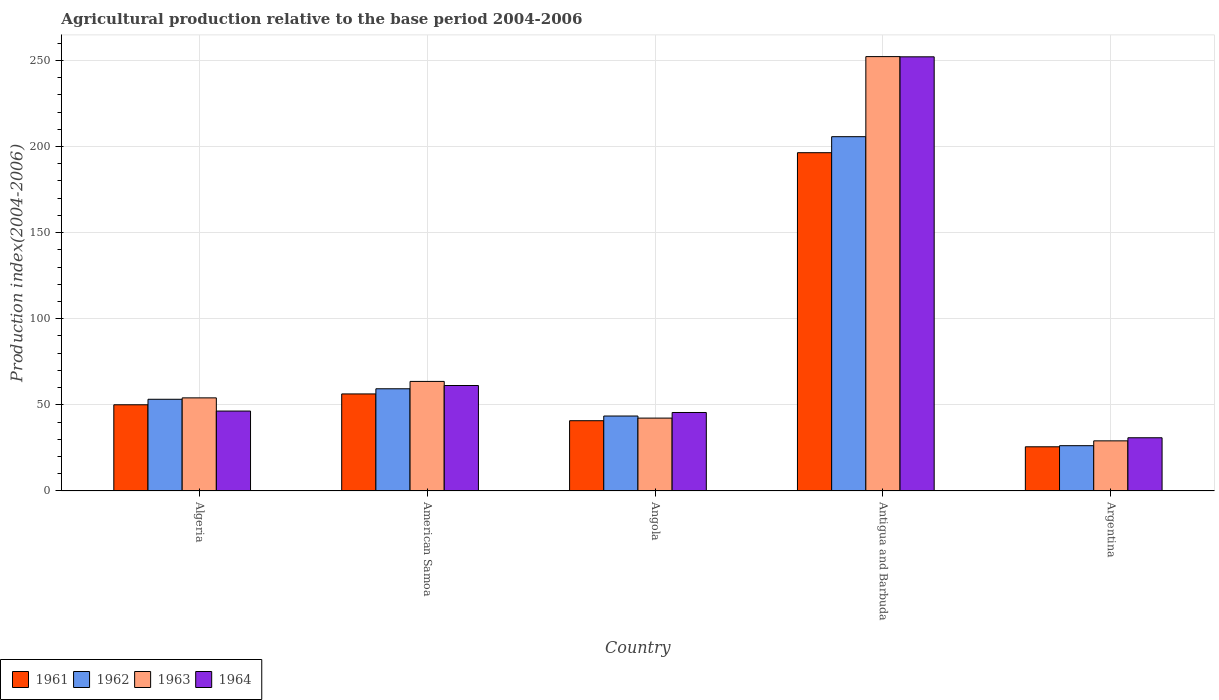How many different coloured bars are there?
Keep it short and to the point. 4. Are the number of bars on each tick of the X-axis equal?
Offer a terse response. Yes. How many bars are there on the 3rd tick from the left?
Provide a succinct answer. 4. How many bars are there on the 1st tick from the right?
Your answer should be compact. 4. What is the label of the 1st group of bars from the left?
Your answer should be compact. Algeria. In how many cases, is the number of bars for a given country not equal to the number of legend labels?
Your answer should be very brief. 0. What is the agricultural production index in 1964 in Angola?
Ensure brevity in your answer.  45.58. Across all countries, what is the maximum agricultural production index in 1964?
Your answer should be compact. 252.1. Across all countries, what is the minimum agricultural production index in 1962?
Keep it short and to the point. 26.31. In which country was the agricultural production index in 1962 maximum?
Your response must be concise. Antigua and Barbuda. What is the total agricultural production index in 1962 in the graph?
Give a very brief answer. 388.18. What is the difference between the agricultural production index in 1961 in Algeria and that in Angola?
Your answer should be compact. 9.25. What is the difference between the agricultural production index in 1961 in Antigua and Barbuda and the agricultural production index in 1962 in Argentina?
Your response must be concise. 170.12. What is the average agricultural production index in 1963 per country?
Keep it short and to the point. 88.27. What is the difference between the agricultural production index of/in 1964 and agricultural production index of/in 1963 in American Samoa?
Ensure brevity in your answer.  -2.38. What is the ratio of the agricultural production index in 1964 in Algeria to that in Angola?
Your response must be concise. 1.02. Is the agricultural production index in 1964 in American Samoa less than that in Angola?
Keep it short and to the point. No. Is the difference between the agricultural production index in 1964 in American Samoa and Argentina greater than the difference between the agricultural production index in 1963 in American Samoa and Argentina?
Keep it short and to the point. No. What is the difference between the highest and the second highest agricultural production index in 1961?
Give a very brief answer. 6.3. What is the difference between the highest and the lowest agricultural production index in 1963?
Ensure brevity in your answer.  223.12. In how many countries, is the agricultural production index in 1963 greater than the average agricultural production index in 1963 taken over all countries?
Give a very brief answer. 1. Is it the case that in every country, the sum of the agricultural production index in 1962 and agricultural production index in 1963 is greater than the sum of agricultural production index in 1964 and agricultural production index in 1961?
Make the answer very short. No. What is the difference between two consecutive major ticks on the Y-axis?
Provide a succinct answer. 50. Are the values on the major ticks of Y-axis written in scientific E-notation?
Keep it short and to the point. No. Where does the legend appear in the graph?
Offer a terse response. Bottom left. How are the legend labels stacked?
Your answer should be compact. Horizontal. What is the title of the graph?
Keep it short and to the point. Agricultural production relative to the base period 2004-2006. What is the label or title of the Y-axis?
Keep it short and to the point. Production index(2004-2006). What is the Production index(2004-2006) of 1961 in Algeria?
Offer a terse response. 50.06. What is the Production index(2004-2006) in 1962 in Algeria?
Provide a short and direct response. 53.26. What is the Production index(2004-2006) in 1963 in Algeria?
Your response must be concise. 54.07. What is the Production index(2004-2006) in 1964 in Algeria?
Provide a succinct answer. 46.42. What is the Production index(2004-2006) of 1961 in American Samoa?
Ensure brevity in your answer.  56.36. What is the Production index(2004-2006) of 1962 in American Samoa?
Offer a very short reply. 59.35. What is the Production index(2004-2006) of 1963 in American Samoa?
Your answer should be very brief. 63.63. What is the Production index(2004-2006) in 1964 in American Samoa?
Offer a terse response. 61.25. What is the Production index(2004-2006) of 1961 in Angola?
Keep it short and to the point. 40.81. What is the Production index(2004-2006) of 1962 in Angola?
Give a very brief answer. 43.53. What is the Production index(2004-2006) in 1963 in Angola?
Offer a terse response. 42.32. What is the Production index(2004-2006) in 1964 in Angola?
Provide a succinct answer. 45.58. What is the Production index(2004-2006) of 1961 in Antigua and Barbuda?
Give a very brief answer. 196.43. What is the Production index(2004-2006) of 1962 in Antigua and Barbuda?
Your response must be concise. 205.73. What is the Production index(2004-2006) of 1963 in Antigua and Barbuda?
Your response must be concise. 252.23. What is the Production index(2004-2006) of 1964 in Antigua and Barbuda?
Make the answer very short. 252.1. What is the Production index(2004-2006) in 1961 in Argentina?
Your response must be concise. 25.67. What is the Production index(2004-2006) of 1962 in Argentina?
Keep it short and to the point. 26.31. What is the Production index(2004-2006) in 1963 in Argentina?
Your answer should be very brief. 29.11. What is the Production index(2004-2006) in 1964 in Argentina?
Keep it short and to the point. 30.91. Across all countries, what is the maximum Production index(2004-2006) of 1961?
Your answer should be compact. 196.43. Across all countries, what is the maximum Production index(2004-2006) of 1962?
Keep it short and to the point. 205.73. Across all countries, what is the maximum Production index(2004-2006) in 1963?
Your answer should be very brief. 252.23. Across all countries, what is the maximum Production index(2004-2006) of 1964?
Ensure brevity in your answer.  252.1. Across all countries, what is the minimum Production index(2004-2006) in 1961?
Your answer should be very brief. 25.67. Across all countries, what is the minimum Production index(2004-2006) of 1962?
Provide a short and direct response. 26.31. Across all countries, what is the minimum Production index(2004-2006) of 1963?
Offer a very short reply. 29.11. Across all countries, what is the minimum Production index(2004-2006) in 1964?
Offer a terse response. 30.91. What is the total Production index(2004-2006) in 1961 in the graph?
Offer a very short reply. 369.33. What is the total Production index(2004-2006) in 1962 in the graph?
Offer a terse response. 388.18. What is the total Production index(2004-2006) of 1963 in the graph?
Keep it short and to the point. 441.36. What is the total Production index(2004-2006) of 1964 in the graph?
Your response must be concise. 436.26. What is the difference between the Production index(2004-2006) of 1961 in Algeria and that in American Samoa?
Keep it short and to the point. -6.3. What is the difference between the Production index(2004-2006) in 1962 in Algeria and that in American Samoa?
Provide a succinct answer. -6.09. What is the difference between the Production index(2004-2006) in 1963 in Algeria and that in American Samoa?
Offer a terse response. -9.56. What is the difference between the Production index(2004-2006) of 1964 in Algeria and that in American Samoa?
Ensure brevity in your answer.  -14.83. What is the difference between the Production index(2004-2006) in 1961 in Algeria and that in Angola?
Ensure brevity in your answer.  9.25. What is the difference between the Production index(2004-2006) in 1962 in Algeria and that in Angola?
Provide a short and direct response. 9.73. What is the difference between the Production index(2004-2006) of 1963 in Algeria and that in Angola?
Give a very brief answer. 11.75. What is the difference between the Production index(2004-2006) of 1964 in Algeria and that in Angola?
Your response must be concise. 0.84. What is the difference between the Production index(2004-2006) in 1961 in Algeria and that in Antigua and Barbuda?
Make the answer very short. -146.37. What is the difference between the Production index(2004-2006) of 1962 in Algeria and that in Antigua and Barbuda?
Offer a terse response. -152.47. What is the difference between the Production index(2004-2006) of 1963 in Algeria and that in Antigua and Barbuda?
Make the answer very short. -198.16. What is the difference between the Production index(2004-2006) of 1964 in Algeria and that in Antigua and Barbuda?
Your response must be concise. -205.68. What is the difference between the Production index(2004-2006) in 1961 in Algeria and that in Argentina?
Ensure brevity in your answer.  24.39. What is the difference between the Production index(2004-2006) of 1962 in Algeria and that in Argentina?
Provide a short and direct response. 26.95. What is the difference between the Production index(2004-2006) in 1963 in Algeria and that in Argentina?
Your response must be concise. 24.96. What is the difference between the Production index(2004-2006) in 1964 in Algeria and that in Argentina?
Keep it short and to the point. 15.51. What is the difference between the Production index(2004-2006) in 1961 in American Samoa and that in Angola?
Make the answer very short. 15.55. What is the difference between the Production index(2004-2006) in 1962 in American Samoa and that in Angola?
Provide a succinct answer. 15.82. What is the difference between the Production index(2004-2006) in 1963 in American Samoa and that in Angola?
Give a very brief answer. 21.31. What is the difference between the Production index(2004-2006) in 1964 in American Samoa and that in Angola?
Your answer should be compact. 15.67. What is the difference between the Production index(2004-2006) of 1961 in American Samoa and that in Antigua and Barbuda?
Your response must be concise. -140.07. What is the difference between the Production index(2004-2006) in 1962 in American Samoa and that in Antigua and Barbuda?
Your answer should be compact. -146.38. What is the difference between the Production index(2004-2006) of 1963 in American Samoa and that in Antigua and Barbuda?
Your response must be concise. -188.6. What is the difference between the Production index(2004-2006) of 1964 in American Samoa and that in Antigua and Barbuda?
Provide a succinct answer. -190.85. What is the difference between the Production index(2004-2006) in 1961 in American Samoa and that in Argentina?
Give a very brief answer. 30.69. What is the difference between the Production index(2004-2006) in 1962 in American Samoa and that in Argentina?
Offer a very short reply. 33.04. What is the difference between the Production index(2004-2006) of 1963 in American Samoa and that in Argentina?
Make the answer very short. 34.52. What is the difference between the Production index(2004-2006) of 1964 in American Samoa and that in Argentina?
Make the answer very short. 30.34. What is the difference between the Production index(2004-2006) of 1961 in Angola and that in Antigua and Barbuda?
Provide a succinct answer. -155.62. What is the difference between the Production index(2004-2006) in 1962 in Angola and that in Antigua and Barbuda?
Make the answer very short. -162.2. What is the difference between the Production index(2004-2006) of 1963 in Angola and that in Antigua and Barbuda?
Ensure brevity in your answer.  -209.91. What is the difference between the Production index(2004-2006) in 1964 in Angola and that in Antigua and Barbuda?
Your answer should be compact. -206.52. What is the difference between the Production index(2004-2006) in 1961 in Angola and that in Argentina?
Your answer should be very brief. 15.14. What is the difference between the Production index(2004-2006) in 1962 in Angola and that in Argentina?
Keep it short and to the point. 17.22. What is the difference between the Production index(2004-2006) in 1963 in Angola and that in Argentina?
Your answer should be very brief. 13.21. What is the difference between the Production index(2004-2006) in 1964 in Angola and that in Argentina?
Provide a short and direct response. 14.67. What is the difference between the Production index(2004-2006) of 1961 in Antigua and Barbuda and that in Argentina?
Offer a terse response. 170.76. What is the difference between the Production index(2004-2006) in 1962 in Antigua and Barbuda and that in Argentina?
Offer a very short reply. 179.42. What is the difference between the Production index(2004-2006) of 1963 in Antigua and Barbuda and that in Argentina?
Ensure brevity in your answer.  223.12. What is the difference between the Production index(2004-2006) in 1964 in Antigua and Barbuda and that in Argentina?
Give a very brief answer. 221.19. What is the difference between the Production index(2004-2006) of 1961 in Algeria and the Production index(2004-2006) of 1962 in American Samoa?
Give a very brief answer. -9.29. What is the difference between the Production index(2004-2006) in 1961 in Algeria and the Production index(2004-2006) in 1963 in American Samoa?
Keep it short and to the point. -13.57. What is the difference between the Production index(2004-2006) in 1961 in Algeria and the Production index(2004-2006) in 1964 in American Samoa?
Ensure brevity in your answer.  -11.19. What is the difference between the Production index(2004-2006) of 1962 in Algeria and the Production index(2004-2006) of 1963 in American Samoa?
Give a very brief answer. -10.37. What is the difference between the Production index(2004-2006) in 1962 in Algeria and the Production index(2004-2006) in 1964 in American Samoa?
Make the answer very short. -7.99. What is the difference between the Production index(2004-2006) in 1963 in Algeria and the Production index(2004-2006) in 1964 in American Samoa?
Offer a very short reply. -7.18. What is the difference between the Production index(2004-2006) in 1961 in Algeria and the Production index(2004-2006) in 1962 in Angola?
Offer a very short reply. 6.53. What is the difference between the Production index(2004-2006) in 1961 in Algeria and the Production index(2004-2006) in 1963 in Angola?
Make the answer very short. 7.74. What is the difference between the Production index(2004-2006) of 1961 in Algeria and the Production index(2004-2006) of 1964 in Angola?
Offer a very short reply. 4.48. What is the difference between the Production index(2004-2006) in 1962 in Algeria and the Production index(2004-2006) in 1963 in Angola?
Offer a very short reply. 10.94. What is the difference between the Production index(2004-2006) in 1962 in Algeria and the Production index(2004-2006) in 1964 in Angola?
Make the answer very short. 7.68. What is the difference between the Production index(2004-2006) of 1963 in Algeria and the Production index(2004-2006) of 1964 in Angola?
Keep it short and to the point. 8.49. What is the difference between the Production index(2004-2006) of 1961 in Algeria and the Production index(2004-2006) of 1962 in Antigua and Barbuda?
Make the answer very short. -155.67. What is the difference between the Production index(2004-2006) in 1961 in Algeria and the Production index(2004-2006) in 1963 in Antigua and Barbuda?
Offer a very short reply. -202.17. What is the difference between the Production index(2004-2006) of 1961 in Algeria and the Production index(2004-2006) of 1964 in Antigua and Barbuda?
Provide a short and direct response. -202.04. What is the difference between the Production index(2004-2006) in 1962 in Algeria and the Production index(2004-2006) in 1963 in Antigua and Barbuda?
Your answer should be compact. -198.97. What is the difference between the Production index(2004-2006) of 1962 in Algeria and the Production index(2004-2006) of 1964 in Antigua and Barbuda?
Offer a very short reply. -198.84. What is the difference between the Production index(2004-2006) in 1963 in Algeria and the Production index(2004-2006) in 1964 in Antigua and Barbuda?
Provide a short and direct response. -198.03. What is the difference between the Production index(2004-2006) of 1961 in Algeria and the Production index(2004-2006) of 1962 in Argentina?
Keep it short and to the point. 23.75. What is the difference between the Production index(2004-2006) in 1961 in Algeria and the Production index(2004-2006) in 1963 in Argentina?
Keep it short and to the point. 20.95. What is the difference between the Production index(2004-2006) of 1961 in Algeria and the Production index(2004-2006) of 1964 in Argentina?
Your response must be concise. 19.15. What is the difference between the Production index(2004-2006) in 1962 in Algeria and the Production index(2004-2006) in 1963 in Argentina?
Make the answer very short. 24.15. What is the difference between the Production index(2004-2006) in 1962 in Algeria and the Production index(2004-2006) in 1964 in Argentina?
Your answer should be very brief. 22.35. What is the difference between the Production index(2004-2006) of 1963 in Algeria and the Production index(2004-2006) of 1964 in Argentina?
Provide a succinct answer. 23.16. What is the difference between the Production index(2004-2006) of 1961 in American Samoa and the Production index(2004-2006) of 1962 in Angola?
Keep it short and to the point. 12.83. What is the difference between the Production index(2004-2006) in 1961 in American Samoa and the Production index(2004-2006) in 1963 in Angola?
Make the answer very short. 14.04. What is the difference between the Production index(2004-2006) in 1961 in American Samoa and the Production index(2004-2006) in 1964 in Angola?
Provide a short and direct response. 10.78. What is the difference between the Production index(2004-2006) of 1962 in American Samoa and the Production index(2004-2006) of 1963 in Angola?
Offer a terse response. 17.03. What is the difference between the Production index(2004-2006) in 1962 in American Samoa and the Production index(2004-2006) in 1964 in Angola?
Give a very brief answer. 13.77. What is the difference between the Production index(2004-2006) in 1963 in American Samoa and the Production index(2004-2006) in 1964 in Angola?
Provide a succinct answer. 18.05. What is the difference between the Production index(2004-2006) in 1961 in American Samoa and the Production index(2004-2006) in 1962 in Antigua and Barbuda?
Keep it short and to the point. -149.37. What is the difference between the Production index(2004-2006) in 1961 in American Samoa and the Production index(2004-2006) in 1963 in Antigua and Barbuda?
Your answer should be very brief. -195.87. What is the difference between the Production index(2004-2006) of 1961 in American Samoa and the Production index(2004-2006) of 1964 in Antigua and Barbuda?
Make the answer very short. -195.74. What is the difference between the Production index(2004-2006) in 1962 in American Samoa and the Production index(2004-2006) in 1963 in Antigua and Barbuda?
Your response must be concise. -192.88. What is the difference between the Production index(2004-2006) in 1962 in American Samoa and the Production index(2004-2006) in 1964 in Antigua and Barbuda?
Your answer should be very brief. -192.75. What is the difference between the Production index(2004-2006) in 1963 in American Samoa and the Production index(2004-2006) in 1964 in Antigua and Barbuda?
Make the answer very short. -188.47. What is the difference between the Production index(2004-2006) of 1961 in American Samoa and the Production index(2004-2006) of 1962 in Argentina?
Your answer should be compact. 30.05. What is the difference between the Production index(2004-2006) of 1961 in American Samoa and the Production index(2004-2006) of 1963 in Argentina?
Your answer should be very brief. 27.25. What is the difference between the Production index(2004-2006) of 1961 in American Samoa and the Production index(2004-2006) of 1964 in Argentina?
Offer a very short reply. 25.45. What is the difference between the Production index(2004-2006) of 1962 in American Samoa and the Production index(2004-2006) of 1963 in Argentina?
Provide a short and direct response. 30.24. What is the difference between the Production index(2004-2006) in 1962 in American Samoa and the Production index(2004-2006) in 1964 in Argentina?
Provide a short and direct response. 28.44. What is the difference between the Production index(2004-2006) of 1963 in American Samoa and the Production index(2004-2006) of 1964 in Argentina?
Ensure brevity in your answer.  32.72. What is the difference between the Production index(2004-2006) of 1961 in Angola and the Production index(2004-2006) of 1962 in Antigua and Barbuda?
Give a very brief answer. -164.92. What is the difference between the Production index(2004-2006) of 1961 in Angola and the Production index(2004-2006) of 1963 in Antigua and Barbuda?
Ensure brevity in your answer.  -211.42. What is the difference between the Production index(2004-2006) in 1961 in Angola and the Production index(2004-2006) in 1964 in Antigua and Barbuda?
Keep it short and to the point. -211.29. What is the difference between the Production index(2004-2006) of 1962 in Angola and the Production index(2004-2006) of 1963 in Antigua and Barbuda?
Make the answer very short. -208.7. What is the difference between the Production index(2004-2006) in 1962 in Angola and the Production index(2004-2006) in 1964 in Antigua and Barbuda?
Make the answer very short. -208.57. What is the difference between the Production index(2004-2006) of 1963 in Angola and the Production index(2004-2006) of 1964 in Antigua and Barbuda?
Offer a terse response. -209.78. What is the difference between the Production index(2004-2006) in 1961 in Angola and the Production index(2004-2006) in 1963 in Argentina?
Offer a very short reply. 11.7. What is the difference between the Production index(2004-2006) in 1961 in Angola and the Production index(2004-2006) in 1964 in Argentina?
Provide a succinct answer. 9.9. What is the difference between the Production index(2004-2006) of 1962 in Angola and the Production index(2004-2006) of 1963 in Argentina?
Make the answer very short. 14.42. What is the difference between the Production index(2004-2006) of 1962 in Angola and the Production index(2004-2006) of 1964 in Argentina?
Your answer should be compact. 12.62. What is the difference between the Production index(2004-2006) of 1963 in Angola and the Production index(2004-2006) of 1964 in Argentina?
Your response must be concise. 11.41. What is the difference between the Production index(2004-2006) of 1961 in Antigua and Barbuda and the Production index(2004-2006) of 1962 in Argentina?
Offer a terse response. 170.12. What is the difference between the Production index(2004-2006) of 1961 in Antigua and Barbuda and the Production index(2004-2006) of 1963 in Argentina?
Offer a terse response. 167.32. What is the difference between the Production index(2004-2006) of 1961 in Antigua and Barbuda and the Production index(2004-2006) of 1964 in Argentina?
Keep it short and to the point. 165.52. What is the difference between the Production index(2004-2006) in 1962 in Antigua and Barbuda and the Production index(2004-2006) in 1963 in Argentina?
Ensure brevity in your answer.  176.62. What is the difference between the Production index(2004-2006) in 1962 in Antigua and Barbuda and the Production index(2004-2006) in 1964 in Argentina?
Give a very brief answer. 174.82. What is the difference between the Production index(2004-2006) in 1963 in Antigua and Barbuda and the Production index(2004-2006) in 1964 in Argentina?
Make the answer very short. 221.32. What is the average Production index(2004-2006) of 1961 per country?
Ensure brevity in your answer.  73.87. What is the average Production index(2004-2006) in 1962 per country?
Give a very brief answer. 77.64. What is the average Production index(2004-2006) in 1963 per country?
Provide a succinct answer. 88.27. What is the average Production index(2004-2006) in 1964 per country?
Offer a very short reply. 87.25. What is the difference between the Production index(2004-2006) of 1961 and Production index(2004-2006) of 1963 in Algeria?
Make the answer very short. -4.01. What is the difference between the Production index(2004-2006) in 1961 and Production index(2004-2006) in 1964 in Algeria?
Keep it short and to the point. 3.64. What is the difference between the Production index(2004-2006) in 1962 and Production index(2004-2006) in 1963 in Algeria?
Your response must be concise. -0.81. What is the difference between the Production index(2004-2006) in 1962 and Production index(2004-2006) in 1964 in Algeria?
Offer a very short reply. 6.84. What is the difference between the Production index(2004-2006) in 1963 and Production index(2004-2006) in 1964 in Algeria?
Offer a terse response. 7.65. What is the difference between the Production index(2004-2006) in 1961 and Production index(2004-2006) in 1962 in American Samoa?
Ensure brevity in your answer.  -2.99. What is the difference between the Production index(2004-2006) in 1961 and Production index(2004-2006) in 1963 in American Samoa?
Provide a short and direct response. -7.27. What is the difference between the Production index(2004-2006) of 1961 and Production index(2004-2006) of 1964 in American Samoa?
Provide a short and direct response. -4.89. What is the difference between the Production index(2004-2006) of 1962 and Production index(2004-2006) of 1963 in American Samoa?
Your answer should be compact. -4.28. What is the difference between the Production index(2004-2006) of 1963 and Production index(2004-2006) of 1964 in American Samoa?
Your response must be concise. 2.38. What is the difference between the Production index(2004-2006) in 1961 and Production index(2004-2006) in 1962 in Angola?
Make the answer very short. -2.72. What is the difference between the Production index(2004-2006) in 1961 and Production index(2004-2006) in 1963 in Angola?
Provide a short and direct response. -1.51. What is the difference between the Production index(2004-2006) in 1961 and Production index(2004-2006) in 1964 in Angola?
Your answer should be very brief. -4.77. What is the difference between the Production index(2004-2006) of 1962 and Production index(2004-2006) of 1963 in Angola?
Make the answer very short. 1.21. What is the difference between the Production index(2004-2006) of 1962 and Production index(2004-2006) of 1964 in Angola?
Offer a terse response. -2.05. What is the difference between the Production index(2004-2006) of 1963 and Production index(2004-2006) of 1964 in Angola?
Provide a short and direct response. -3.26. What is the difference between the Production index(2004-2006) in 1961 and Production index(2004-2006) in 1963 in Antigua and Barbuda?
Offer a terse response. -55.8. What is the difference between the Production index(2004-2006) in 1961 and Production index(2004-2006) in 1964 in Antigua and Barbuda?
Give a very brief answer. -55.67. What is the difference between the Production index(2004-2006) of 1962 and Production index(2004-2006) of 1963 in Antigua and Barbuda?
Provide a short and direct response. -46.5. What is the difference between the Production index(2004-2006) in 1962 and Production index(2004-2006) in 1964 in Antigua and Barbuda?
Offer a very short reply. -46.37. What is the difference between the Production index(2004-2006) of 1963 and Production index(2004-2006) of 1964 in Antigua and Barbuda?
Offer a very short reply. 0.13. What is the difference between the Production index(2004-2006) of 1961 and Production index(2004-2006) of 1962 in Argentina?
Your answer should be compact. -0.64. What is the difference between the Production index(2004-2006) in 1961 and Production index(2004-2006) in 1963 in Argentina?
Make the answer very short. -3.44. What is the difference between the Production index(2004-2006) of 1961 and Production index(2004-2006) of 1964 in Argentina?
Provide a short and direct response. -5.24. What is the difference between the Production index(2004-2006) of 1962 and Production index(2004-2006) of 1963 in Argentina?
Offer a very short reply. -2.8. What is the difference between the Production index(2004-2006) of 1962 and Production index(2004-2006) of 1964 in Argentina?
Your answer should be compact. -4.6. What is the ratio of the Production index(2004-2006) of 1961 in Algeria to that in American Samoa?
Make the answer very short. 0.89. What is the ratio of the Production index(2004-2006) of 1962 in Algeria to that in American Samoa?
Provide a succinct answer. 0.9. What is the ratio of the Production index(2004-2006) of 1963 in Algeria to that in American Samoa?
Offer a terse response. 0.85. What is the ratio of the Production index(2004-2006) in 1964 in Algeria to that in American Samoa?
Provide a succinct answer. 0.76. What is the ratio of the Production index(2004-2006) of 1961 in Algeria to that in Angola?
Make the answer very short. 1.23. What is the ratio of the Production index(2004-2006) in 1962 in Algeria to that in Angola?
Provide a short and direct response. 1.22. What is the ratio of the Production index(2004-2006) of 1963 in Algeria to that in Angola?
Give a very brief answer. 1.28. What is the ratio of the Production index(2004-2006) in 1964 in Algeria to that in Angola?
Your response must be concise. 1.02. What is the ratio of the Production index(2004-2006) in 1961 in Algeria to that in Antigua and Barbuda?
Ensure brevity in your answer.  0.25. What is the ratio of the Production index(2004-2006) of 1962 in Algeria to that in Antigua and Barbuda?
Ensure brevity in your answer.  0.26. What is the ratio of the Production index(2004-2006) in 1963 in Algeria to that in Antigua and Barbuda?
Make the answer very short. 0.21. What is the ratio of the Production index(2004-2006) in 1964 in Algeria to that in Antigua and Barbuda?
Provide a succinct answer. 0.18. What is the ratio of the Production index(2004-2006) in 1961 in Algeria to that in Argentina?
Make the answer very short. 1.95. What is the ratio of the Production index(2004-2006) in 1962 in Algeria to that in Argentina?
Your response must be concise. 2.02. What is the ratio of the Production index(2004-2006) in 1963 in Algeria to that in Argentina?
Your response must be concise. 1.86. What is the ratio of the Production index(2004-2006) of 1964 in Algeria to that in Argentina?
Offer a very short reply. 1.5. What is the ratio of the Production index(2004-2006) of 1961 in American Samoa to that in Angola?
Give a very brief answer. 1.38. What is the ratio of the Production index(2004-2006) of 1962 in American Samoa to that in Angola?
Your answer should be compact. 1.36. What is the ratio of the Production index(2004-2006) in 1963 in American Samoa to that in Angola?
Ensure brevity in your answer.  1.5. What is the ratio of the Production index(2004-2006) in 1964 in American Samoa to that in Angola?
Ensure brevity in your answer.  1.34. What is the ratio of the Production index(2004-2006) in 1961 in American Samoa to that in Antigua and Barbuda?
Your answer should be compact. 0.29. What is the ratio of the Production index(2004-2006) in 1962 in American Samoa to that in Antigua and Barbuda?
Provide a short and direct response. 0.29. What is the ratio of the Production index(2004-2006) of 1963 in American Samoa to that in Antigua and Barbuda?
Your answer should be very brief. 0.25. What is the ratio of the Production index(2004-2006) in 1964 in American Samoa to that in Antigua and Barbuda?
Offer a very short reply. 0.24. What is the ratio of the Production index(2004-2006) in 1961 in American Samoa to that in Argentina?
Offer a very short reply. 2.2. What is the ratio of the Production index(2004-2006) of 1962 in American Samoa to that in Argentina?
Give a very brief answer. 2.26. What is the ratio of the Production index(2004-2006) in 1963 in American Samoa to that in Argentina?
Provide a short and direct response. 2.19. What is the ratio of the Production index(2004-2006) in 1964 in American Samoa to that in Argentina?
Keep it short and to the point. 1.98. What is the ratio of the Production index(2004-2006) of 1961 in Angola to that in Antigua and Barbuda?
Ensure brevity in your answer.  0.21. What is the ratio of the Production index(2004-2006) of 1962 in Angola to that in Antigua and Barbuda?
Give a very brief answer. 0.21. What is the ratio of the Production index(2004-2006) in 1963 in Angola to that in Antigua and Barbuda?
Ensure brevity in your answer.  0.17. What is the ratio of the Production index(2004-2006) of 1964 in Angola to that in Antigua and Barbuda?
Keep it short and to the point. 0.18. What is the ratio of the Production index(2004-2006) of 1961 in Angola to that in Argentina?
Offer a very short reply. 1.59. What is the ratio of the Production index(2004-2006) in 1962 in Angola to that in Argentina?
Your answer should be very brief. 1.65. What is the ratio of the Production index(2004-2006) of 1963 in Angola to that in Argentina?
Offer a very short reply. 1.45. What is the ratio of the Production index(2004-2006) in 1964 in Angola to that in Argentina?
Offer a terse response. 1.47. What is the ratio of the Production index(2004-2006) of 1961 in Antigua and Barbuda to that in Argentina?
Ensure brevity in your answer.  7.65. What is the ratio of the Production index(2004-2006) of 1962 in Antigua and Barbuda to that in Argentina?
Ensure brevity in your answer.  7.82. What is the ratio of the Production index(2004-2006) in 1963 in Antigua and Barbuda to that in Argentina?
Keep it short and to the point. 8.66. What is the ratio of the Production index(2004-2006) of 1964 in Antigua and Barbuda to that in Argentina?
Offer a very short reply. 8.16. What is the difference between the highest and the second highest Production index(2004-2006) of 1961?
Provide a succinct answer. 140.07. What is the difference between the highest and the second highest Production index(2004-2006) of 1962?
Offer a very short reply. 146.38. What is the difference between the highest and the second highest Production index(2004-2006) in 1963?
Ensure brevity in your answer.  188.6. What is the difference between the highest and the second highest Production index(2004-2006) in 1964?
Keep it short and to the point. 190.85. What is the difference between the highest and the lowest Production index(2004-2006) in 1961?
Ensure brevity in your answer.  170.76. What is the difference between the highest and the lowest Production index(2004-2006) of 1962?
Provide a succinct answer. 179.42. What is the difference between the highest and the lowest Production index(2004-2006) in 1963?
Offer a terse response. 223.12. What is the difference between the highest and the lowest Production index(2004-2006) of 1964?
Offer a terse response. 221.19. 